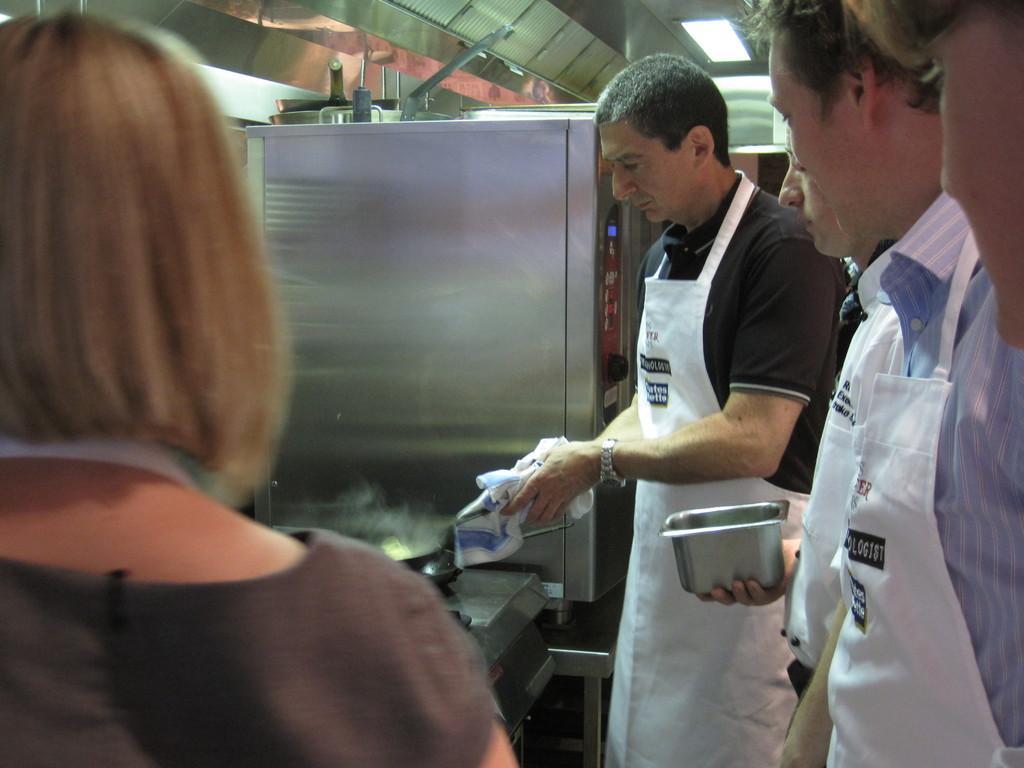Could you give a brief overview of what you see in this image? In the center of the image a man is standing and cooking and holding cloth, vessel. In the middle of the image we can see a locker. On the right side of the image we can see some persons, a man is holding a vessel. On the left side of the image a lady is there. In the background of the image we can see some objects, roof, light. At the bottom of the image we can see stove, stand, floor. 